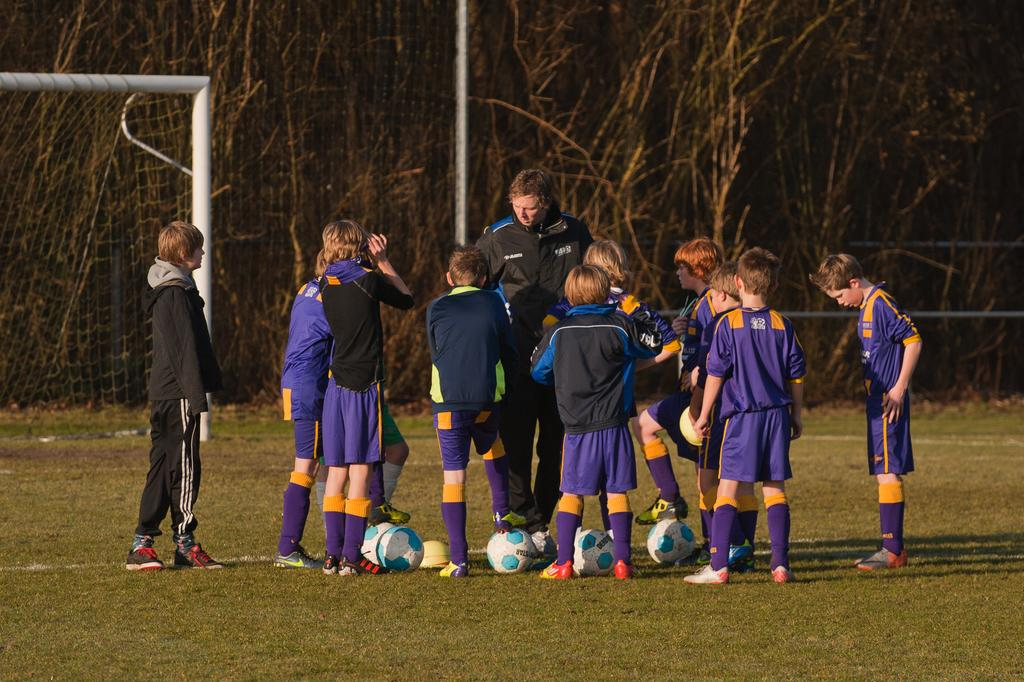Where was the image taken? The image is taken outdoors. Who is present in the image? There is a group of kids in the image. What are the kids doing in the image? The kids are standing on the ground. What objects are on the ground with the kids? There are balls on the ground. What can be seen in the background of the image? There are trees and a net visible in the background. What are the kids writing on the ground in the image? There is no indication that the kids are writing on the ground in the image. How are the kids controlling the basketball in the image? There is no basketball present in the image, so the kids are not controlling a basketball. 